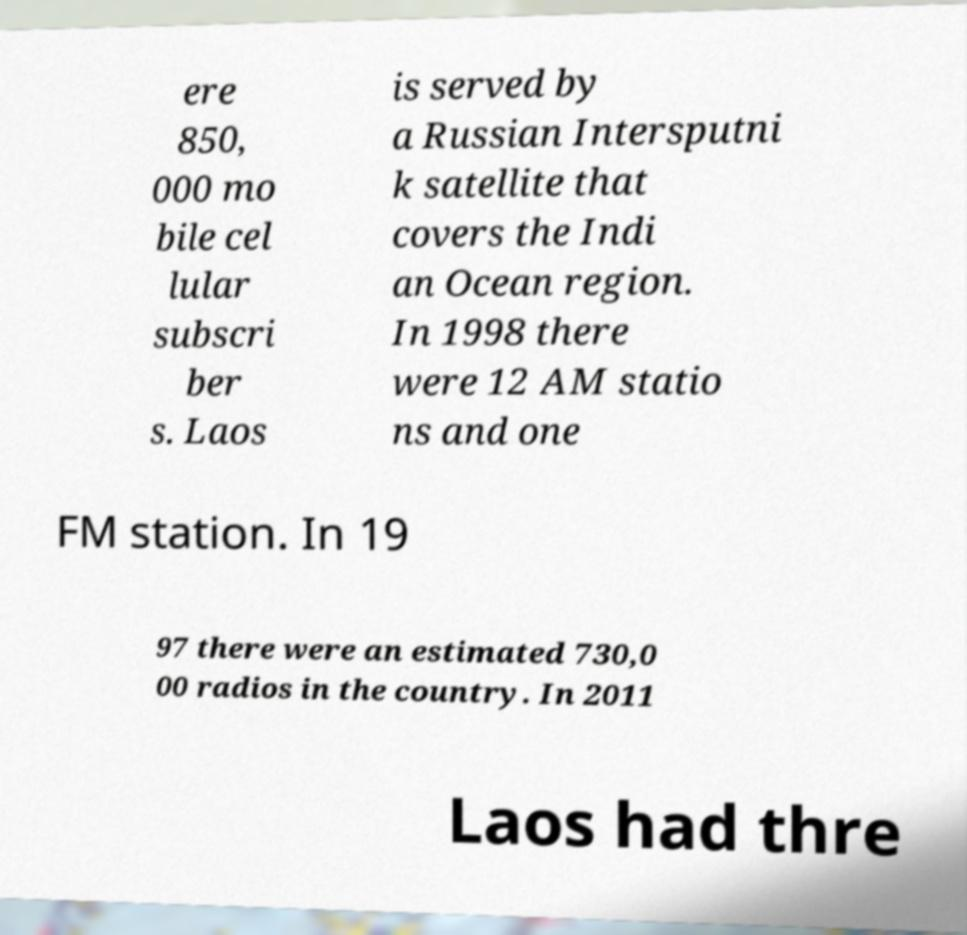Please read and relay the text visible in this image. What does it say? ere 850, 000 mo bile cel lular subscri ber s. Laos is served by a Russian Intersputni k satellite that covers the Indi an Ocean region. In 1998 there were 12 AM statio ns and one FM station. In 19 97 there were an estimated 730,0 00 radios in the country. In 2011 Laos had thre 